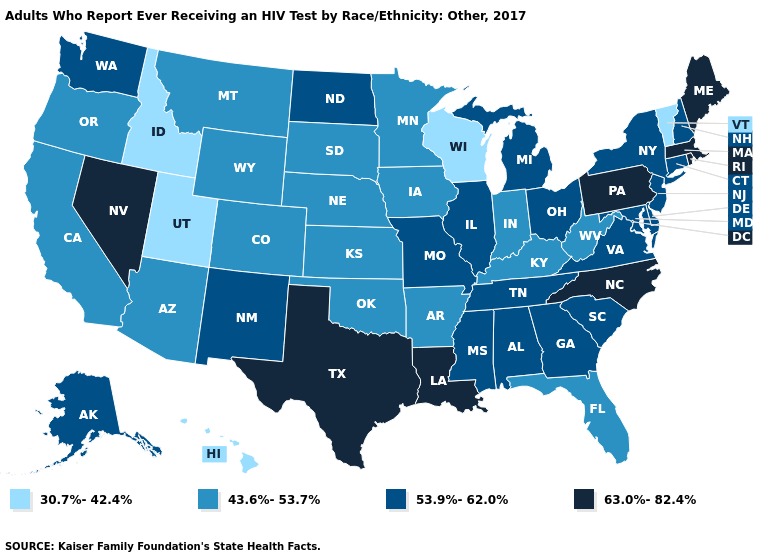What is the value of West Virginia?
Concise answer only. 43.6%-53.7%. Does Hawaii have a higher value than Georgia?
Short answer required. No. What is the value of Kentucky?
Give a very brief answer. 43.6%-53.7%. What is the highest value in the South ?
Give a very brief answer. 63.0%-82.4%. Does Wisconsin have the lowest value in the USA?
Give a very brief answer. Yes. Name the states that have a value in the range 63.0%-82.4%?
Concise answer only. Louisiana, Maine, Massachusetts, Nevada, North Carolina, Pennsylvania, Rhode Island, Texas. Name the states that have a value in the range 53.9%-62.0%?
Quick response, please. Alabama, Alaska, Connecticut, Delaware, Georgia, Illinois, Maryland, Michigan, Mississippi, Missouri, New Hampshire, New Jersey, New Mexico, New York, North Dakota, Ohio, South Carolina, Tennessee, Virginia, Washington. Does Rhode Island have the highest value in the USA?
Give a very brief answer. Yes. Does South Carolina have the lowest value in the South?
Write a very short answer. No. What is the value of Michigan?
Give a very brief answer. 53.9%-62.0%. What is the value of Oklahoma?
Answer briefly. 43.6%-53.7%. Name the states that have a value in the range 53.9%-62.0%?
Give a very brief answer. Alabama, Alaska, Connecticut, Delaware, Georgia, Illinois, Maryland, Michigan, Mississippi, Missouri, New Hampshire, New Jersey, New Mexico, New York, North Dakota, Ohio, South Carolina, Tennessee, Virginia, Washington. What is the value of Connecticut?
Be succinct. 53.9%-62.0%. Which states have the lowest value in the USA?
Give a very brief answer. Hawaii, Idaho, Utah, Vermont, Wisconsin. Name the states that have a value in the range 43.6%-53.7%?
Concise answer only. Arizona, Arkansas, California, Colorado, Florida, Indiana, Iowa, Kansas, Kentucky, Minnesota, Montana, Nebraska, Oklahoma, Oregon, South Dakota, West Virginia, Wyoming. 